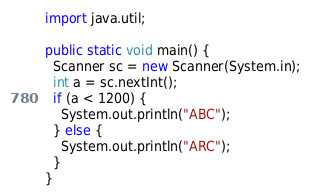<code> <loc_0><loc_0><loc_500><loc_500><_Java_>import java.util;

public static void main() {
  Scanner sc = new Scanner(System.in);
  int a = sc.nextInt();
  if (a < 1200) {
    System.out.println("ABC");
  } else {
    System.out.println("ARC");
  }
}
</code> 